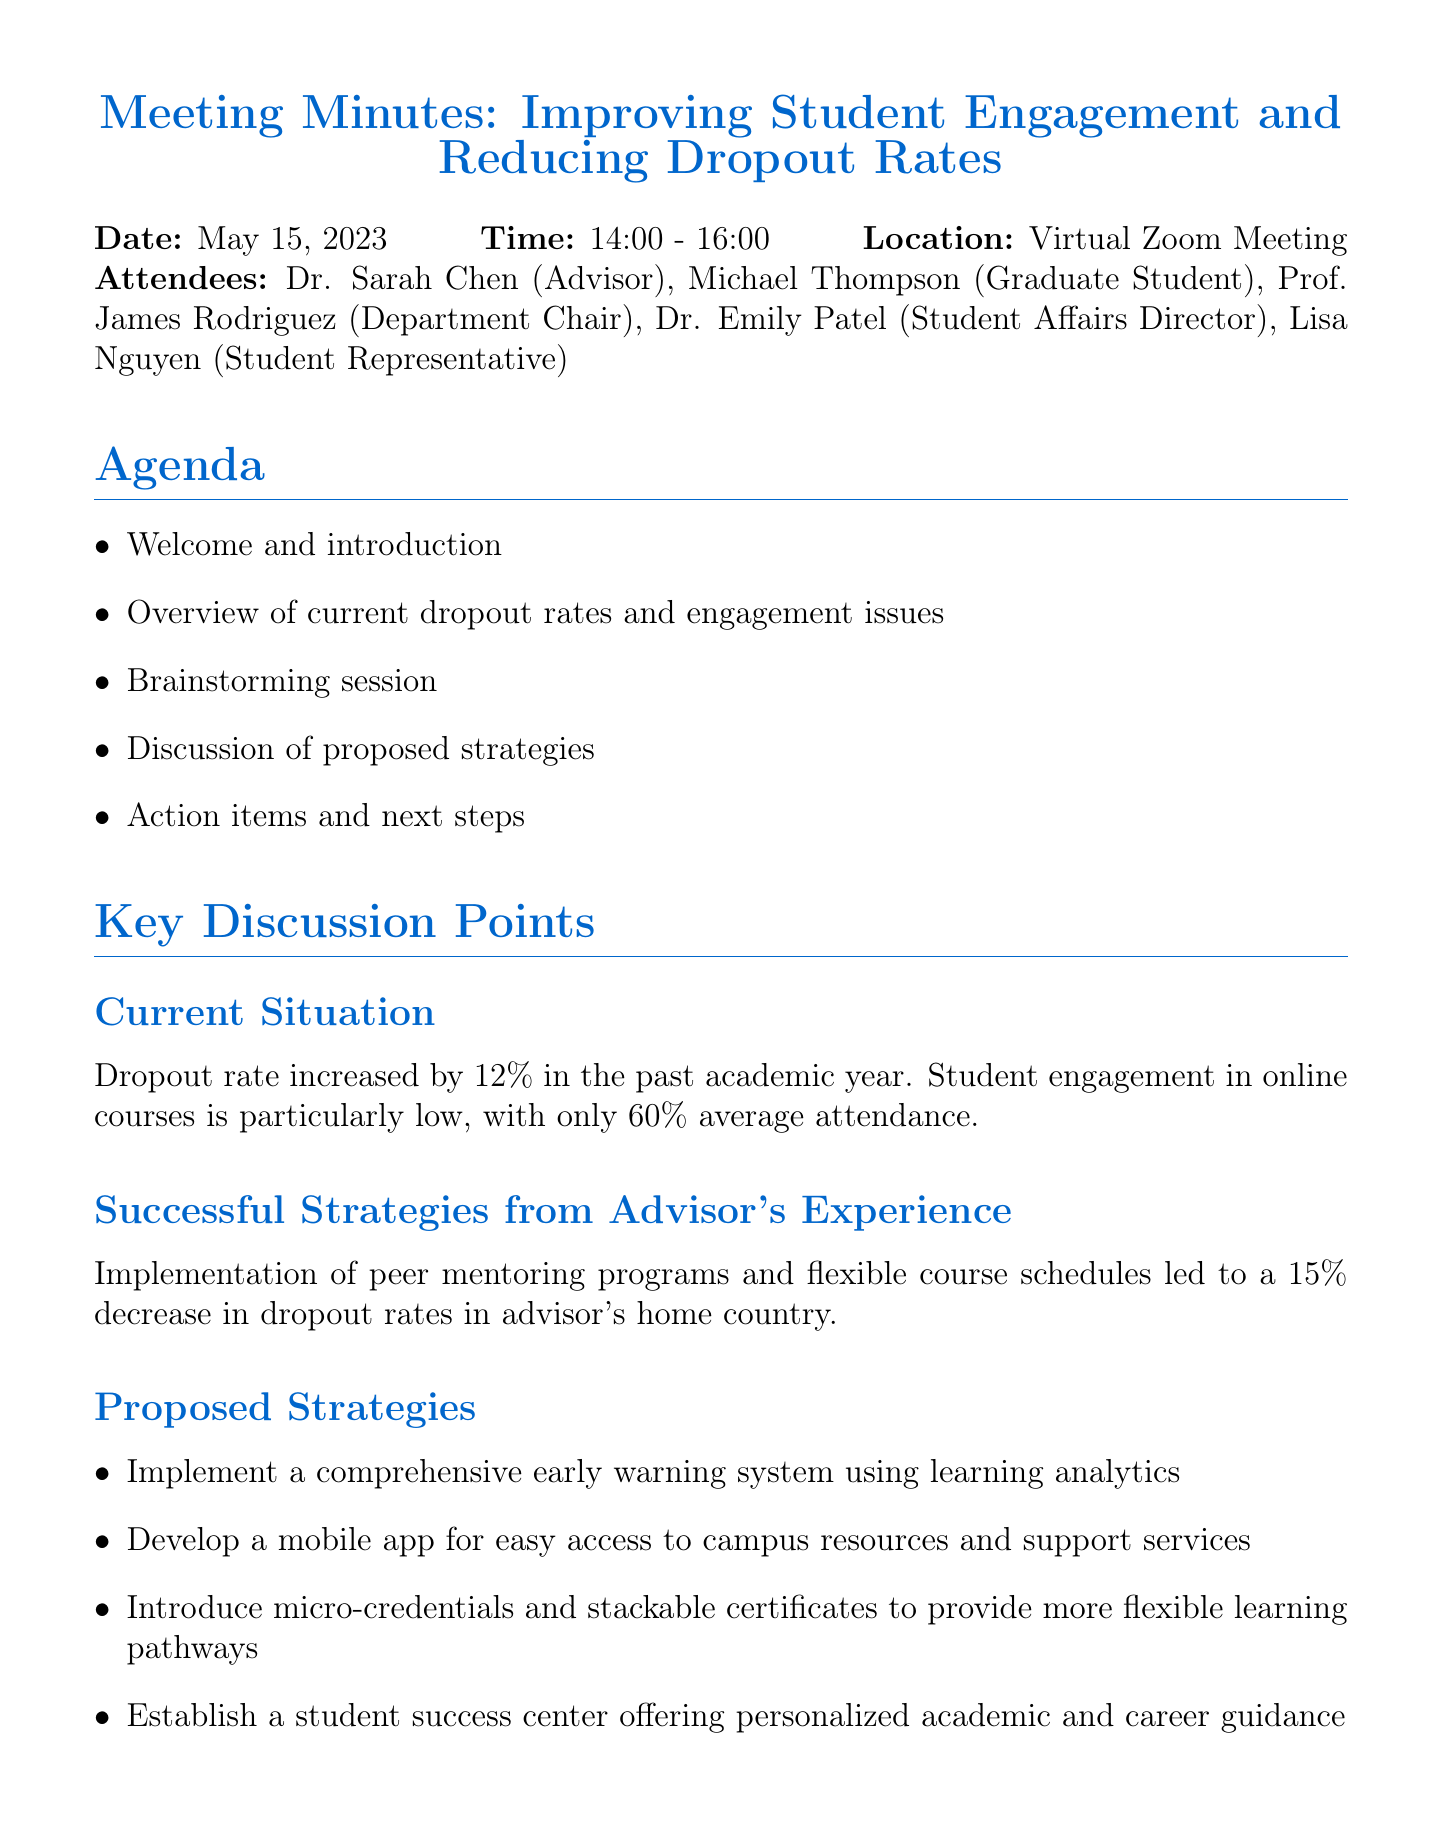What is the date of the meeting? The date of the meeting is explicitly stated in the document as "May 15, 2023."
Answer: May 15, 2023 Who is responsible for conducting the student survey? The document lists action items and the responsible individuals, indicating that Lisa Nguyen is responsible for the survey.
Answer: Lisa Nguyen What was the increase in dropout rate over the past academic year? The document reports a specific percentage increase in dropout rates, which is 12%.
Answer: 12% Which strategy led to a 15% decrease in dropout rates in the advisor's home country? The document mentions successful strategies, specifically peer mentoring programs and flexible course schedules as leading to the decrease.
Answer: Peer mentoring programs and flexible course schedules What is the deadline for the budget proposal for the student success center? The document specifies the deadline for action items, noting that the budget proposal is due on June 15, 2023.
Answer: June 15, 2023 What time is the next meeting scheduled for? The document includes details about the next meeting, explicitly stating the time as "14:00 - 16:00."
Answer: 14:00 - 16:00 How many proposed strategies were discussed in the meeting? The document outlines four proposed strategies, showing the total number discussed.
Answer: Four What is a key theme of the brainstorming session? The document indicates the brainstormed focus was on strategies to improve student engagement and reduce dropout rates.
Answer: Strategies to improve student engagement and reduce dropout rates 